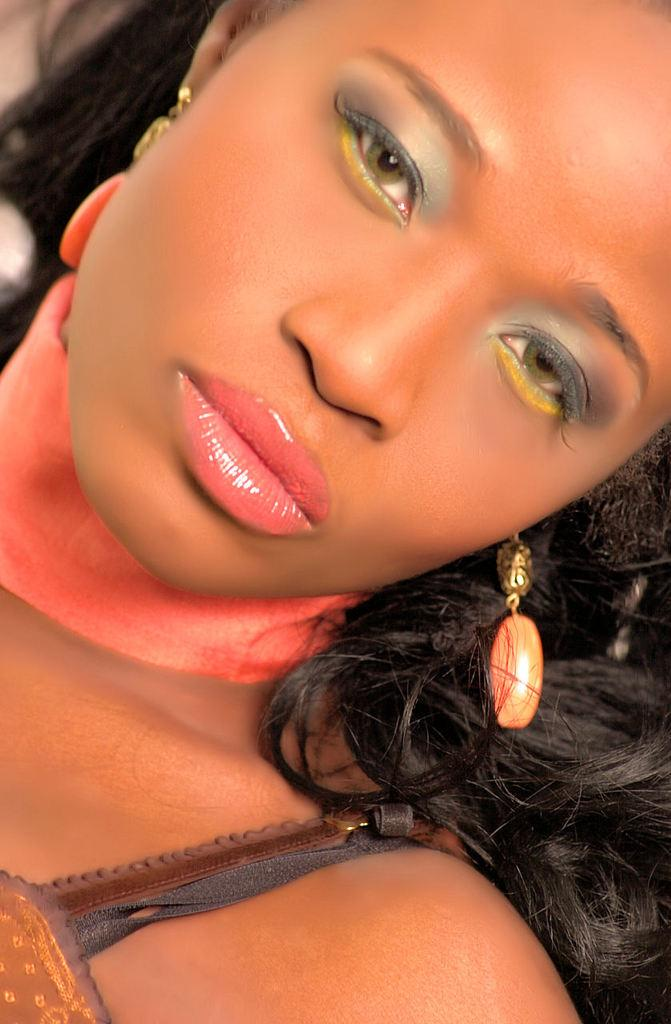Who or what is present in the image? There is a person in the image. What is the person wearing in the image? The person is wearing a brown dress and orange color earrings. What type of record is the person holding in the image? There is no record present in the image; the person is only wearing a brown dress and orange color earrings. 